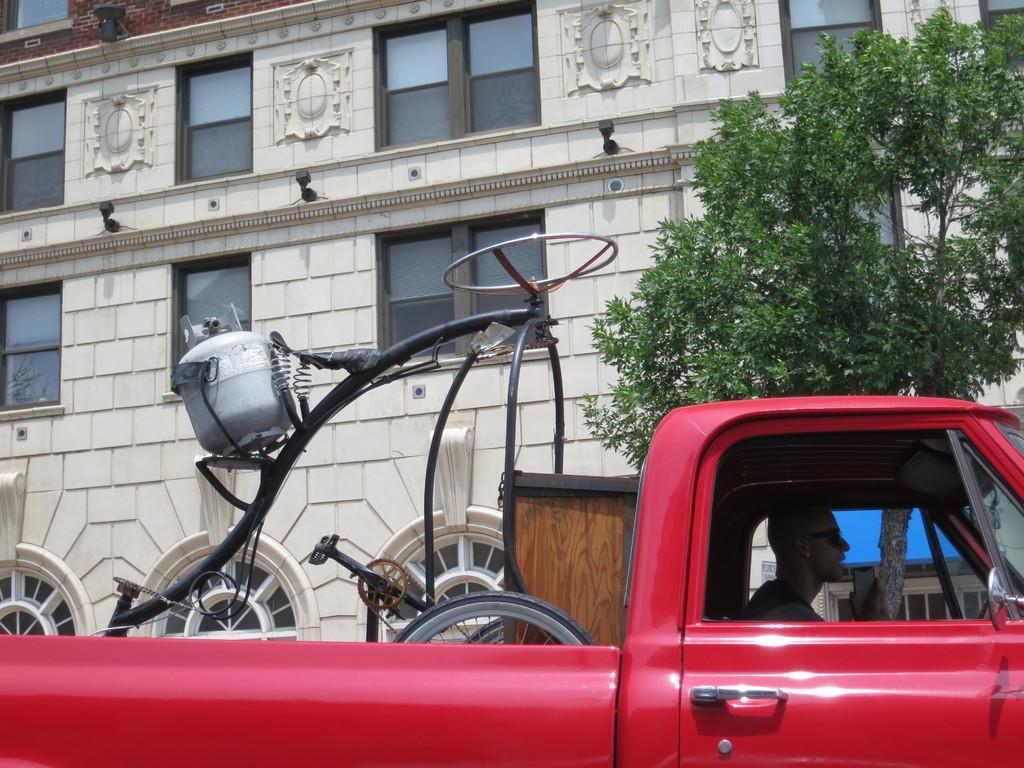Describe this image in one or two sentences. In this image I can see there is a truck and there is a man driving it. There are few objects placed in the truck and there is a building in the backdrop and it has windows and there are trees. 